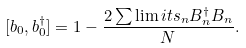Convert formula to latex. <formula><loc_0><loc_0><loc_500><loc_500>[ b _ { 0 } , b _ { 0 } ^ { \dagger } ] = 1 - \frac { 2 \sum \lim i t s _ { n } B _ { n } ^ { \dagger } B _ { n } } { N } .</formula> 